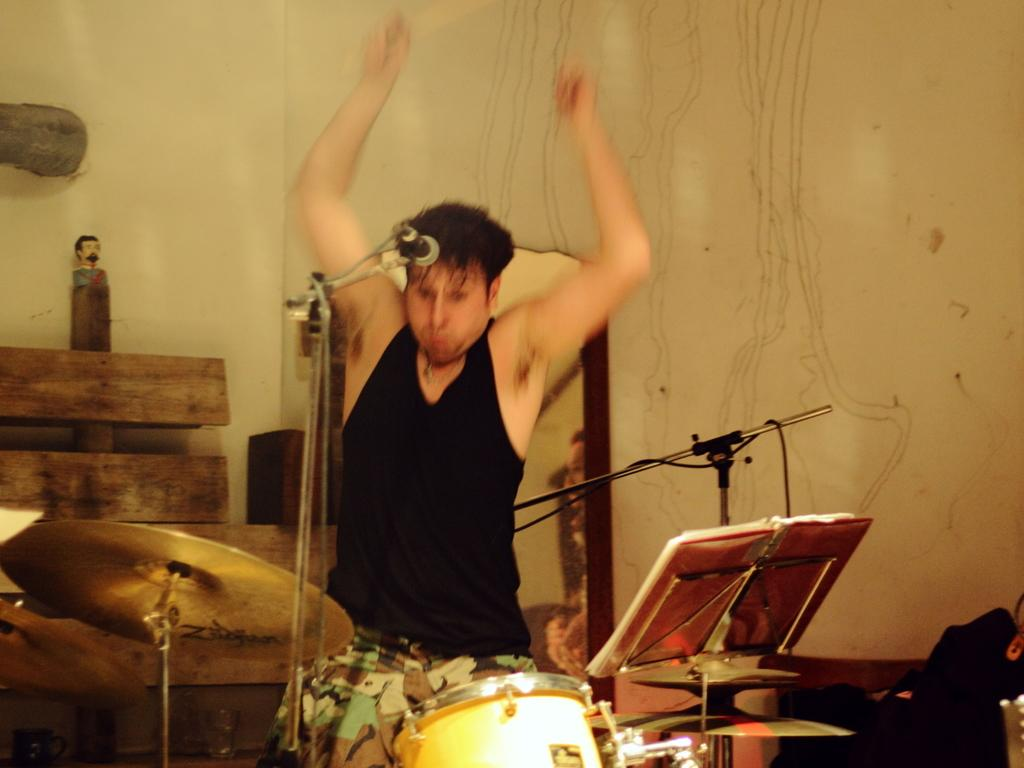What is the person in the image doing? The person is playing a musical instrument. What object is present to amplify the person's voice or sound? There is a microphone with a stand in the image. What can be seen behind the person in the image? There is a wall visible in the background of the image. What type of blood is visible on the wall in the image? There is no blood visible on the wall in the image. How does the person blow into the instrument in the image? The image does not show the person blowing into the instrument, as it only shows the person playing the instrument. 